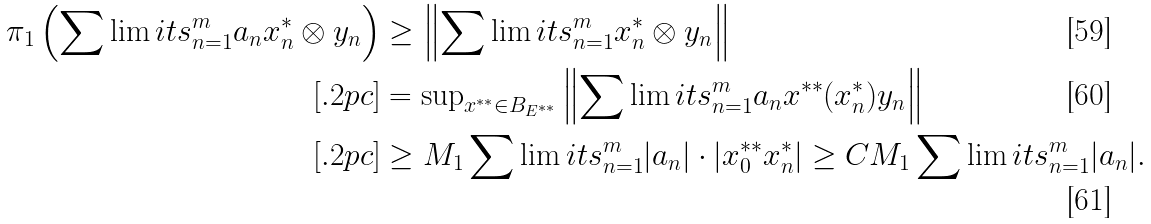<formula> <loc_0><loc_0><loc_500><loc_500>\pi _ { 1 } \left ( \sum \lim i t s _ { n = 1 } ^ { m } a _ { n } x _ { n } ^ { * } \otimes y _ { n } \right ) & \geq \left \| \sum \lim i t s _ { n = 1 } ^ { m } x _ { n } ^ { * } \otimes y _ { n } \right \| \\ [ . 2 p c ] & = { \sup } _ { x ^ { * * } \in B _ { E ^ { * * } } } \left \| \sum \lim i t s _ { n = 1 } ^ { m } a _ { n } x ^ { * * } ( x _ { n } ^ { * } ) y _ { n } \right \| \\ [ . 2 p c ] & \geq M _ { 1 } \sum \lim i t s _ { n = 1 } ^ { m } | a _ { n } | \cdot | x _ { 0 } ^ { * * } x _ { n } ^ { * } | \geq C M _ { 1 } \sum \lim i t s _ { n = 1 } ^ { m } | a _ { n } | .</formula> 